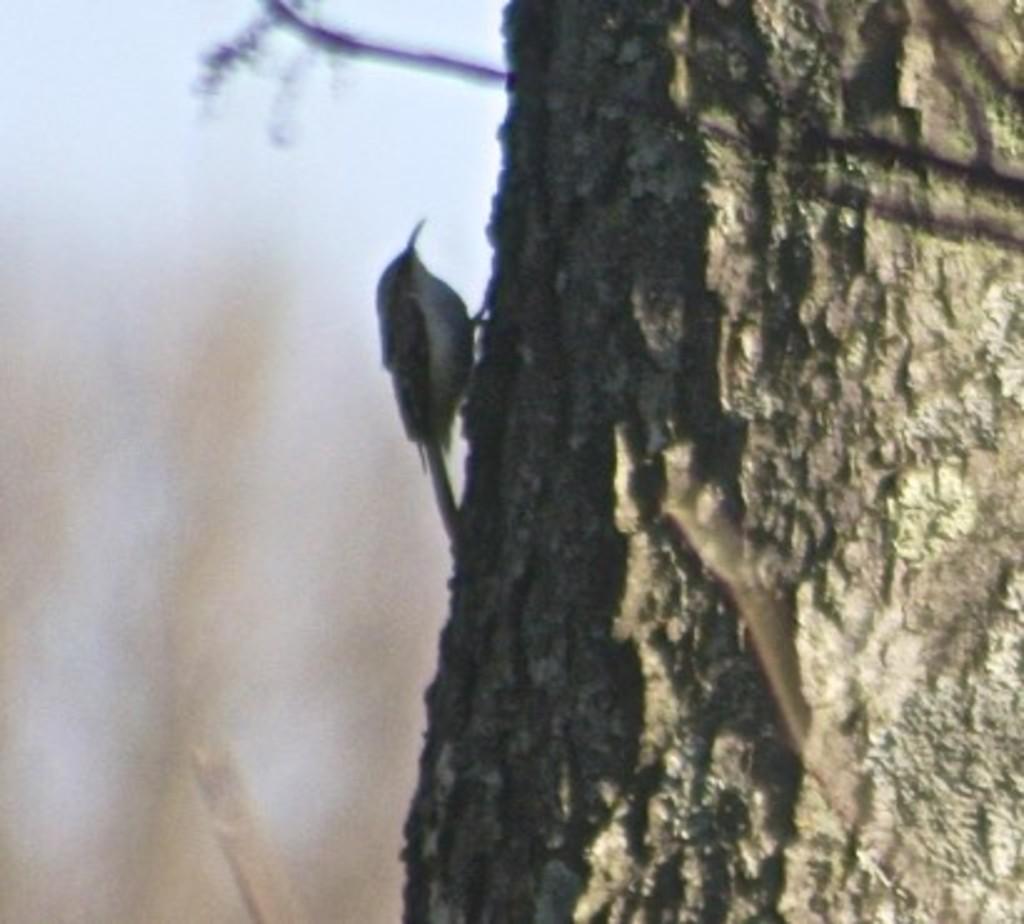Describe this image in one or two sentences. In this picture I can see the trunk in front and I see a bird on it and I see that it is blurred in the background. 